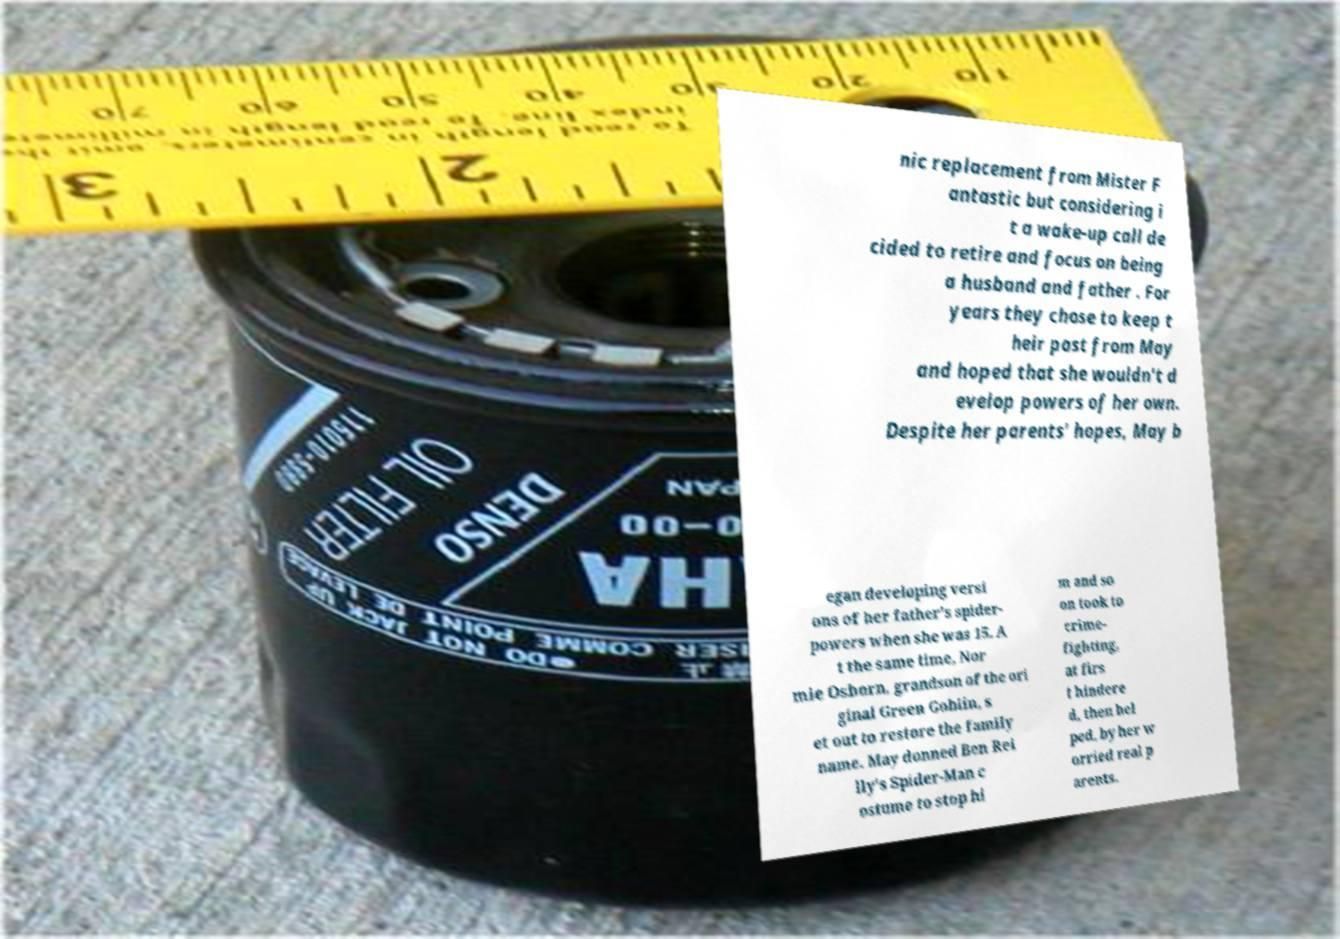Could you extract and type out the text from this image? nic replacement from Mister F antastic but considering i t a wake-up call de cided to retire and focus on being a husband and father . For years they chose to keep t heir past from May and hoped that she wouldn't d evelop powers of her own. Despite her parents' hopes, May b egan developing versi ons of her father's spider- powers when she was 15. A t the same time, Nor mie Osborn, grandson of the ori ginal Green Goblin, s et out to restore the family name. May donned Ben Rei lly's Spider-Man c ostume to stop hi m and so on took to crime- fighting, at firs t hindere d, then hel ped, by her w orried real p arents. 